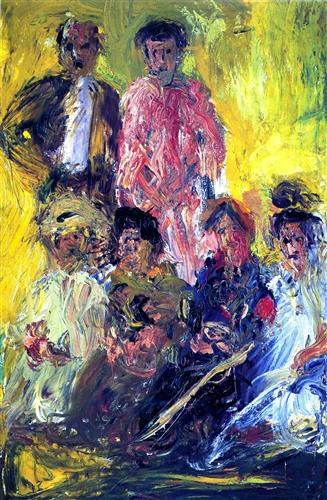Can you describe the main features of this image for me? The image depicts a lively and colorful scene with several figures portrayed in a spontaneous and expressionistic style. Rich, warm tones and loose brushwork create a sense of movement, suggesting an informal gathering or a social event. The faces and clothing of the figures are somewhat abstracted, focusing on the overall mood and atmosphere rather than detailed realism. The background is dominated by a vivid yellow, which provides a stark contrast to the cooler hues and dark outlines of the figures, adding to the painting's vibrancy and depth. 